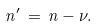<formula> <loc_0><loc_0><loc_500><loc_500>n ^ { \prime } \, = \, n - \nu .</formula> 